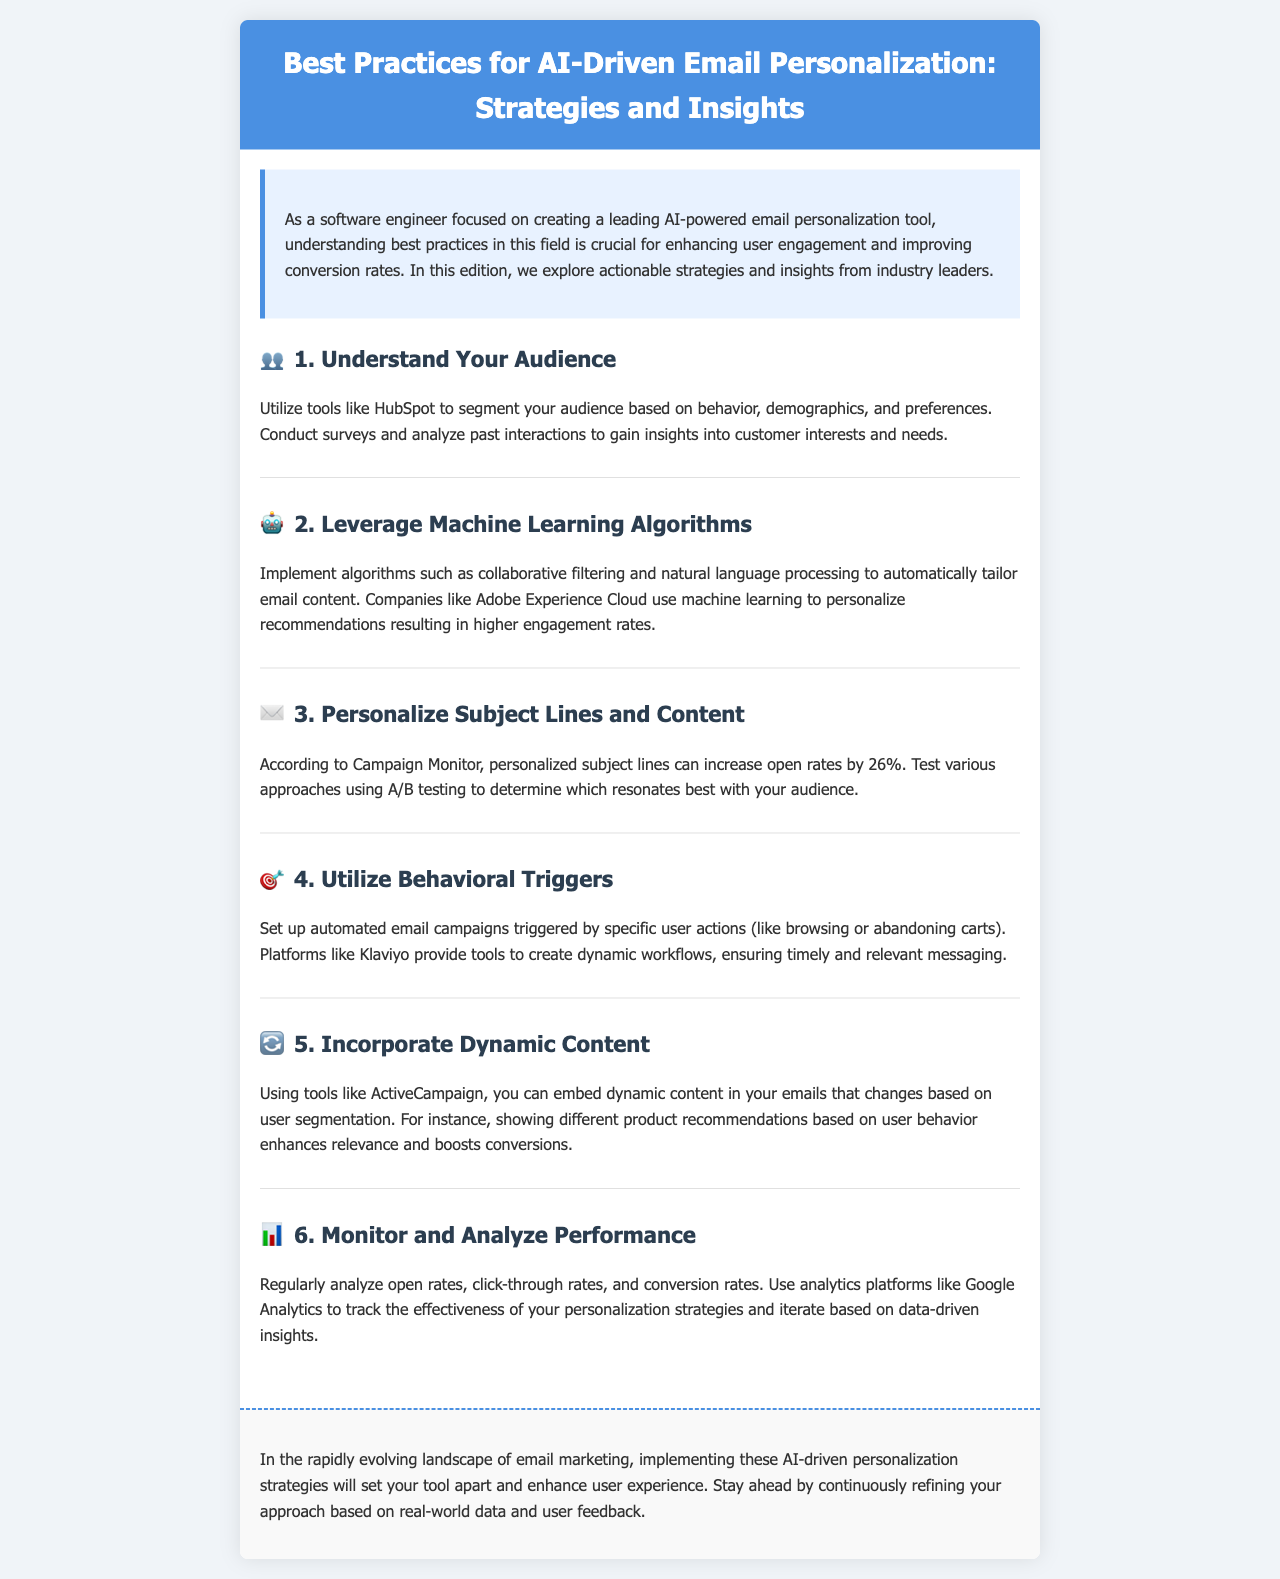What is the main focus of the newsletter? The main focus of the newsletter is on best practices for AI-driven email personalization, providing strategies and insights.
Answer: AI-driven email personalization What can personalized subject lines increase? Personalized subject lines can increase open rates by a specific percentage mentioned in the document.
Answer: 26% Which tool is recommended for audience segmentation? The document mentions a specific tool that can be used for segmenting the audience based on behavior and demographics.
Answer: HubSpot What is one way to monitor performance mentioned? The newsletter suggests a specific platform for analyzing the effectiveness of personalization strategies.
Answer: Google Analytics Which algorithm is mentioned for tailoring email content? The document names a specific algorithm that can be implemented for tailoring email content automatically.
Answer: Collaborative filtering What is the benefit of utilizing behavioral triggers? The document highlights a key advantage of setting up automated campaigns based on user actions.
Answer: Timely and relevant messaging How many sections are included in the content? The newsletter has a specific number of sections presenting different strategies for AI-driven email personalization.
Answer: 6 What enhances relevance according to the document? The document details how a specific technique can enhance relevance in email content.
Answer: Dynamic content 